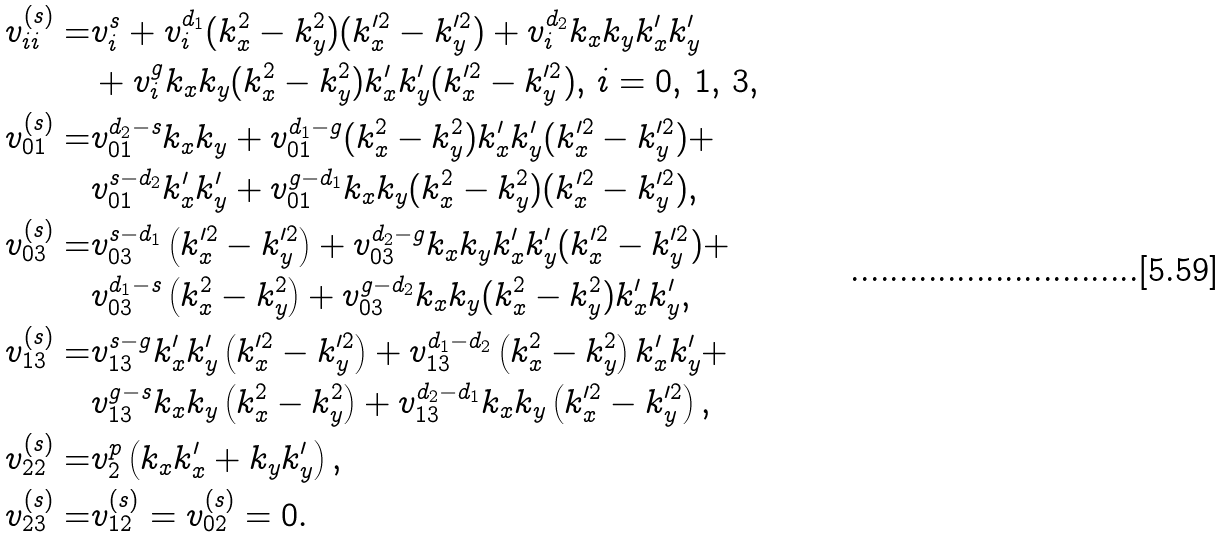<formula> <loc_0><loc_0><loc_500><loc_500>v _ { i i } ^ { ( s ) } = & v _ { i } ^ { s } + v _ { i } ^ { d _ { 1 } } ( k _ { x } ^ { 2 } - k _ { y } ^ { 2 } ) ( k _ { x } ^ { \prime 2 } - k _ { y } ^ { \prime 2 } ) + v _ { i } ^ { d _ { 2 } } k _ { x } k _ { y } k _ { x } ^ { \prime } k _ { y } ^ { \prime } \\ & + v _ { i } ^ { g } k _ { x } k _ { y } ( k _ { x } ^ { 2 } - k _ { y } ^ { 2 } ) k _ { x } ^ { \prime } k _ { y } ^ { \prime } ( k _ { x } ^ { \prime 2 } - k _ { y } ^ { \prime 2 } ) , \, i = 0 , \, 1 , \, 3 , \\ v _ { 0 1 } ^ { ( s ) } = & v _ { 0 1 } ^ { d _ { 2 } - s } k _ { x } k _ { y } + v _ { 0 1 } ^ { d _ { 1 } - g } ( k _ { x } ^ { 2 } - k _ { y } ^ { 2 } ) k _ { x } ^ { \prime } k _ { y } ^ { \prime } ( k _ { x } ^ { \prime 2 } - k _ { y } ^ { \prime 2 } ) + \\ & v _ { 0 1 } ^ { s - d _ { 2 } } k _ { x } ^ { \prime } k _ { y } ^ { \prime } + v _ { 0 1 } ^ { g - d _ { 1 } } k _ { x } k _ { y } ( k _ { x } ^ { 2 } - k _ { y } ^ { 2 } ) ( k _ { x } ^ { \prime 2 } - k _ { y } ^ { \prime 2 } ) , \\ v _ { 0 3 } ^ { ( s ) } = & v _ { 0 3 } ^ { s - d _ { 1 } } \left ( k _ { x } ^ { \prime 2 } - k _ { y } ^ { \prime 2 } \right ) + v _ { 0 3 } ^ { d _ { 2 } - g } k _ { x } k _ { y } k _ { x } ^ { \prime } k _ { y } ^ { \prime } ( k _ { x } ^ { \prime 2 } - k _ { y } ^ { \prime 2 } ) + \\ & v _ { 0 3 } ^ { d _ { 1 } - s } \left ( k _ { x } ^ { 2 } - k _ { y } ^ { 2 } \right ) + v _ { 0 3 } ^ { g - d _ { 2 } } k _ { x } k _ { y } ( k _ { x } ^ { 2 } - k _ { y } ^ { 2 } ) k _ { x } ^ { \prime } k _ { y } ^ { \prime } , \\ v _ { 1 3 } ^ { ( s ) } = & v _ { 1 3 } ^ { s - g } k _ { x } ^ { \prime } k _ { y } ^ { \prime } \left ( k _ { x } ^ { \prime 2 } - k _ { y } ^ { \prime 2 } \right ) + v _ { 1 3 } ^ { d _ { 1 } - d _ { 2 } } \left ( k _ { x } ^ { 2 } - k _ { y } ^ { 2 } \right ) k _ { x } ^ { \prime } k _ { y } ^ { \prime } + \\ & v _ { 1 3 } ^ { g - s } k _ { x } k _ { y } \left ( k _ { x } ^ { 2 } - k _ { y } ^ { 2 } \right ) + v _ { 1 3 } ^ { d _ { 2 } - d _ { 1 } } k _ { x } k _ { y } \left ( k _ { x } ^ { \prime 2 } - k _ { y } ^ { \prime 2 } \right ) , \\ v _ { 2 2 } ^ { ( s ) } = & v _ { 2 } ^ { p } \left ( k _ { x } k _ { x } ^ { \prime } + k _ { y } k _ { y } ^ { \prime } \right ) , \\ v _ { 2 3 } ^ { ( s ) } = & v _ { 1 2 } ^ { ( s ) } = v _ { 0 2 } ^ { ( s ) } = 0 .</formula> 